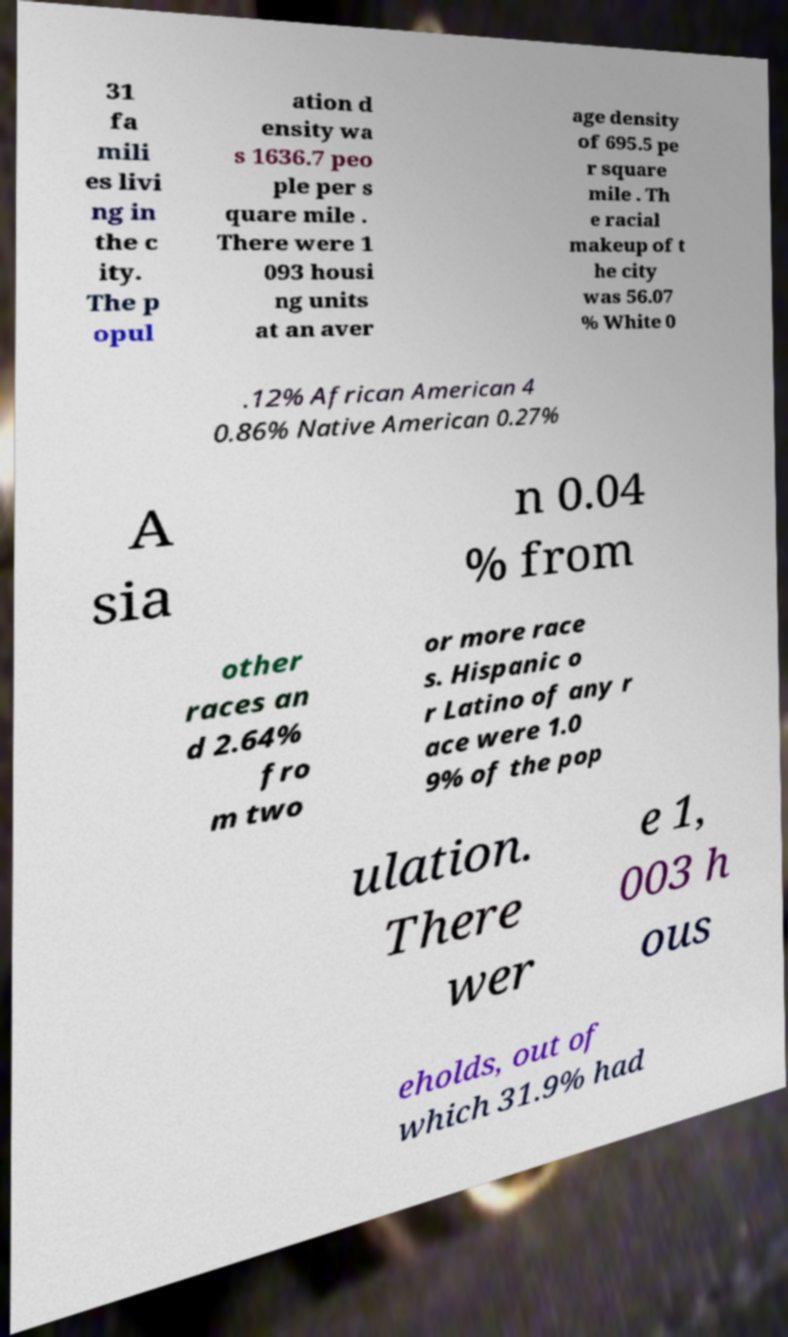Could you assist in decoding the text presented in this image and type it out clearly? 31 fa mili es livi ng in the c ity. The p opul ation d ensity wa s 1636.7 peo ple per s quare mile . There were 1 093 housi ng units at an aver age density of 695.5 pe r square mile . Th e racial makeup of t he city was 56.07 % White 0 .12% African American 4 0.86% Native American 0.27% A sia n 0.04 % from other races an d 2.64% fro m two or more race s. Hispanic o r Latino of any r ace were 1.0 9% of the pop ulation. There wer e 1, 003 h ous eholds, out of which 31.9% had 